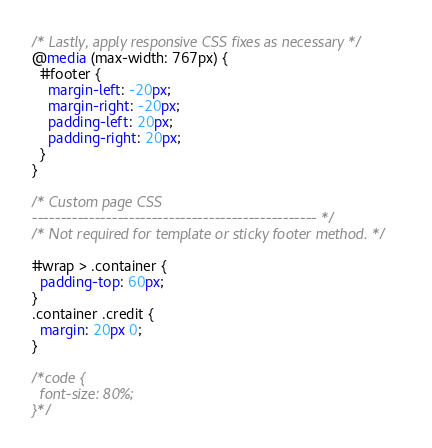<code> <loc_0><loc_0><loc_500><loc_500><_CSS_>/* Lastly, apply responsive CSS fixes as necessary */
@media (max-width: 767px) {
  #footer {
    margin-left: -20px;
    margin-right: -20px;
    padding-left: 20px;
    padding-right: 20px;
  }
}

/* Custom page CSS
-------------------------------------------------- */
/* Not required for template or sticky footer method. */

#wrap > .container {
  padding-top: 60px;
}
.container .credit {
  margin: 20px 0;
}

/*code {
  font-size: 80%;
}*/</code> 